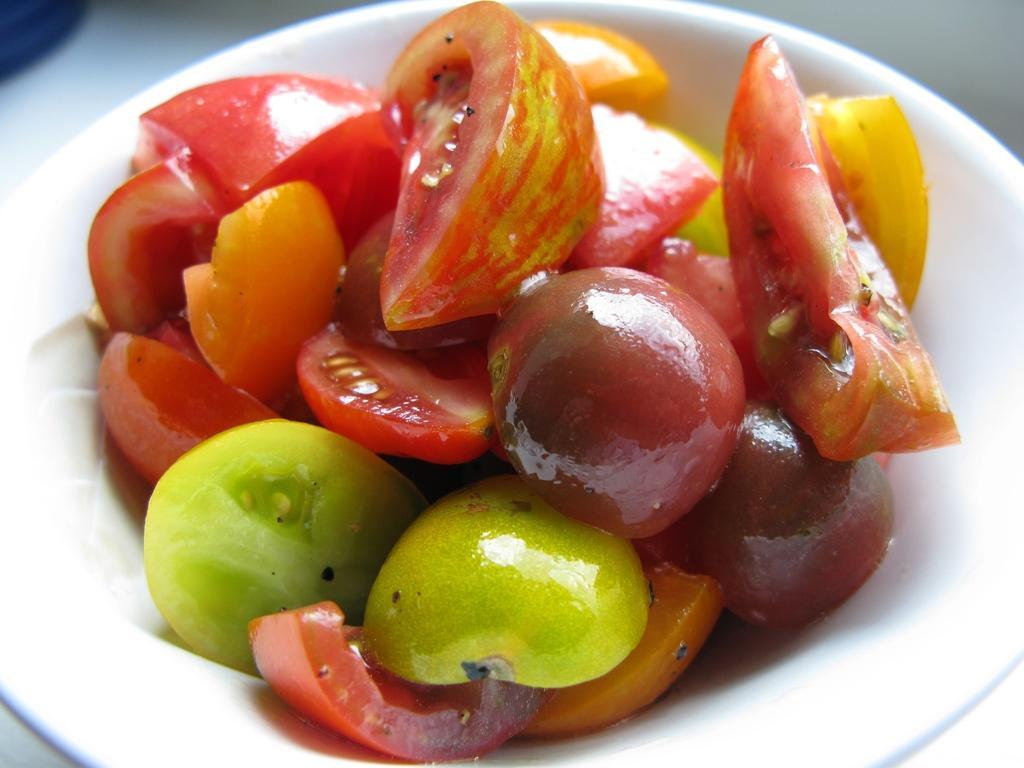Please provide a concise description of this image. In this image I can see few vegetables in a bowl. 